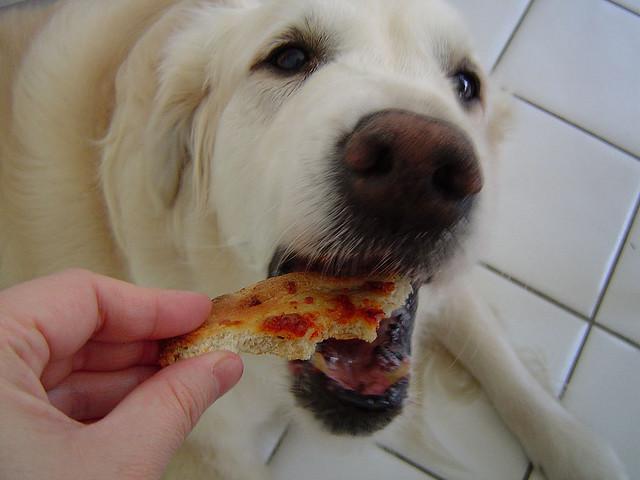How many fingers are in the picture?
Give a very brief answer. 4. How many dogs are there?
Give a very brief answer. 1. How many dogs are seen?
Give a very brief answer. 1. 